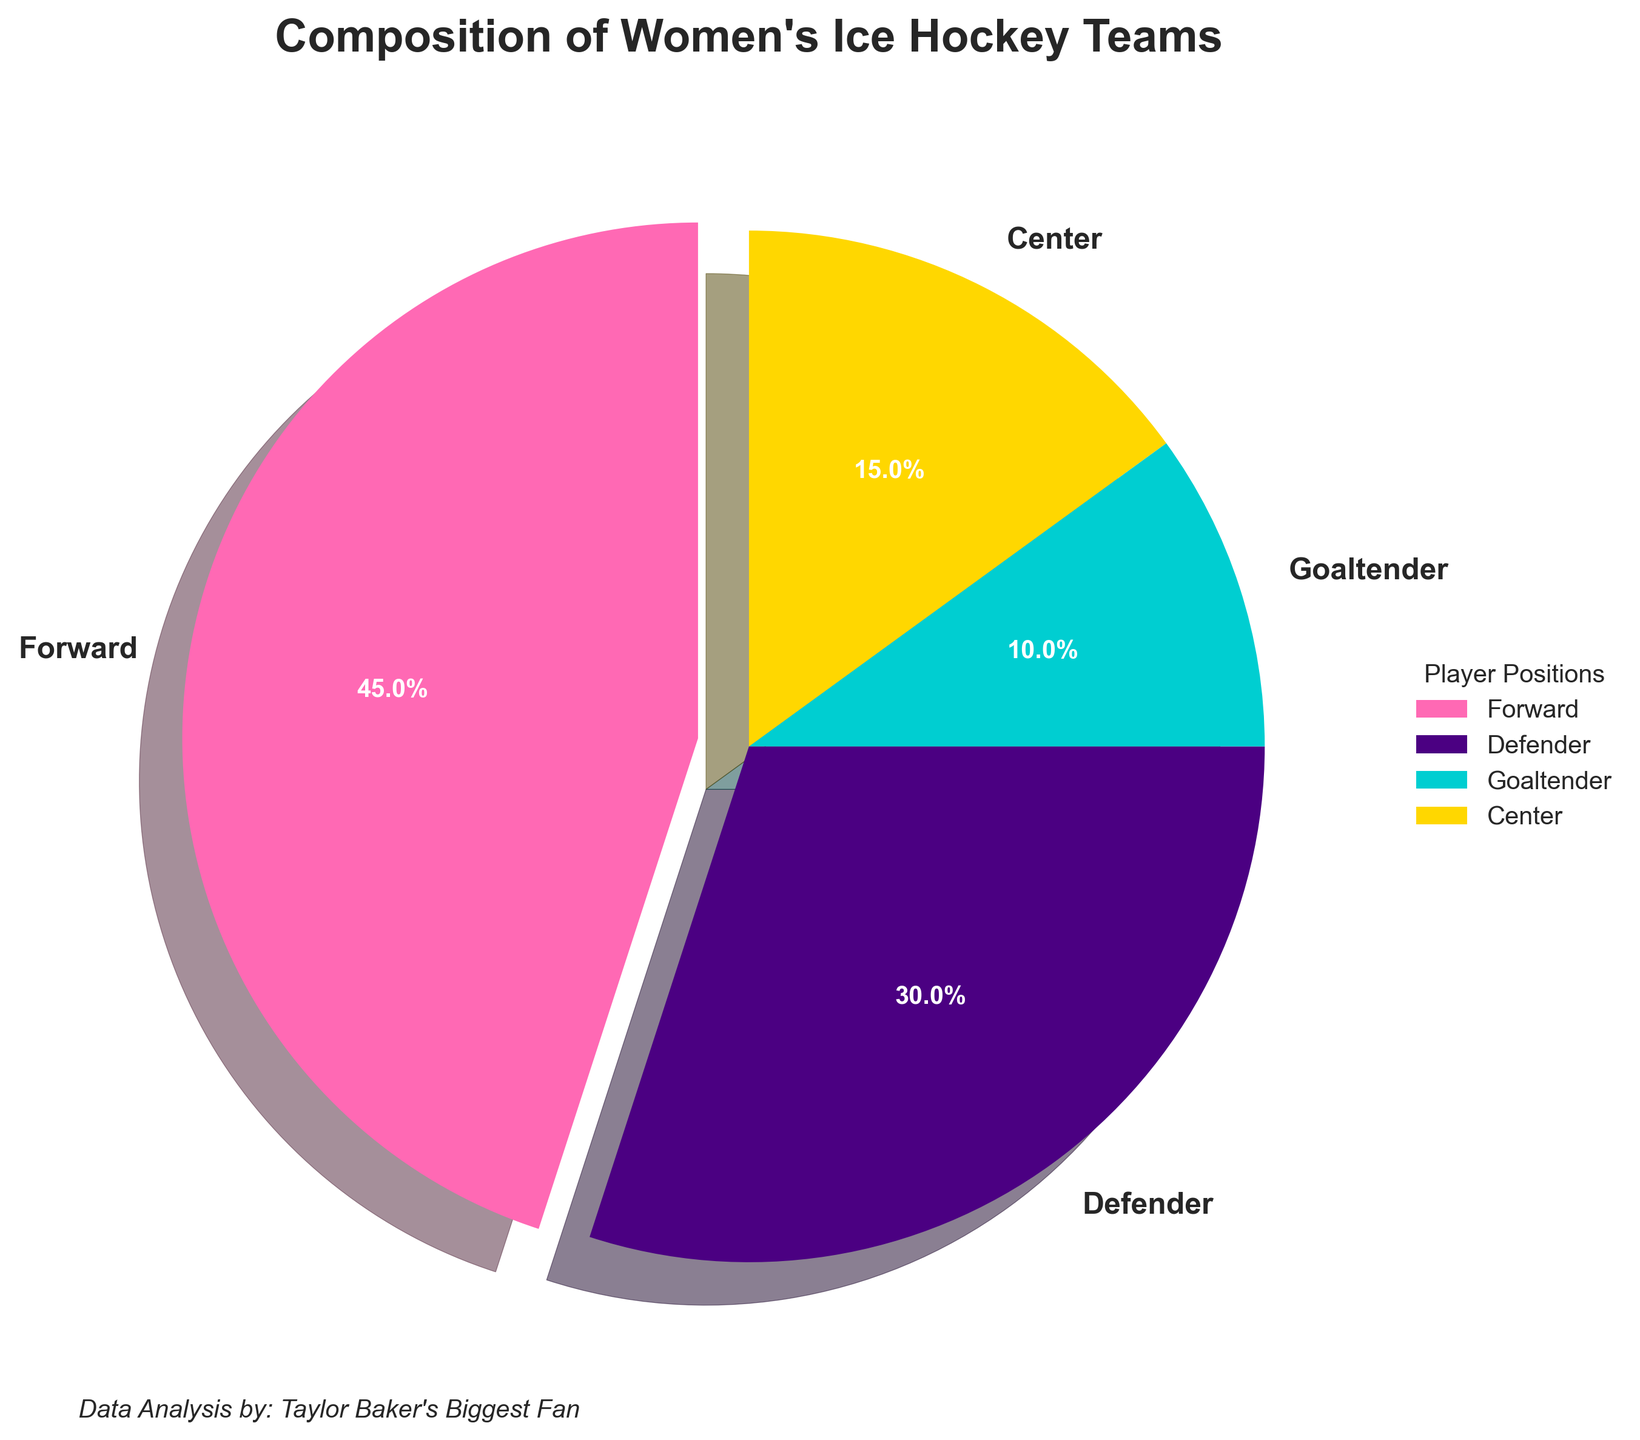What percentage of the team is made up of forwards and defenders combined? The figure shows that 45% of the team is made up of forwards and 30% is made up of defenders. Adding these together results in 45% + 30% = 75%.
Answer: 75% Which player position has the smallest representation on the team? The goaltender position has the smallest percentage on the chart at 10%.
Answer: Goaltender How many times larger is the percentage of forwards compared to goaltenders? The percentage of forwards is 45%, while the percentage of goaltenders is 10%. To find how many times larger the forwards' percentage is, divide 45% by 10%, which is 45/10 = 4.5 times.
Answer: 4.5 What is the difference in percentages between centers and defenders on the team? The figure shows that 30% of the team is made up of defenders and 15% is made up of centers. The difference is 30% - 15% = 15%.
Answer: 15% What is the overall representation of core positions (forwards, defenders, and centers) excluding goaltenders? Adding the percentages of forwards (45%), defenders (30%), and centers (15%) results in 45% + 30% + 15% = 90%.
Answer: 90% What color is used to represent the forward position in the pie chart? The forward position is represented by a pink color in the pie chart.
Answer: Pink Is the percentage of defenders more than double the percentage of centers? The percentage of defenders is 30%, and double the percentage of centers (15%) is 2 * 15% = 30%. Since 30% is equal to 30%, the percentage of defenders is exactly double that of centers.
Answer: No Which player position has a wedge that is visually emphasized or "exploded" in the pie chart? The forward position has a wedge that is emphasized or "exploded" in the pie chart.
Answer: Forward What does the text located at the bottom left corner of the plot say? The text at the bottom left corner of the plot says, "Data Analysis by: Taylor Baker's Biggest Fan".
Answer: Data Analysis by: Taylor Baker's Biggest Fan 